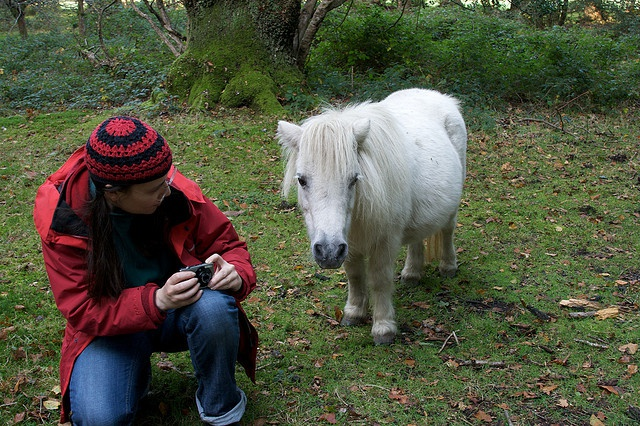Describe the objects in this image and their specific colors. I can see people in black, maroon, brown, and navy tones and horse in black, lightgray, darkgray, and gray tones in this image. 